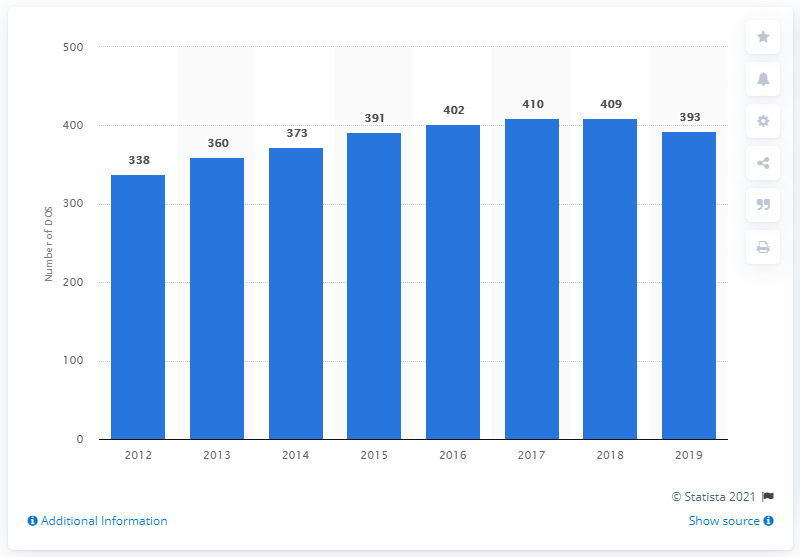Mention a couple of crucial points in this snapshot. Salvatore Ferragamo operated 393 stores as of December 31, 2019. 